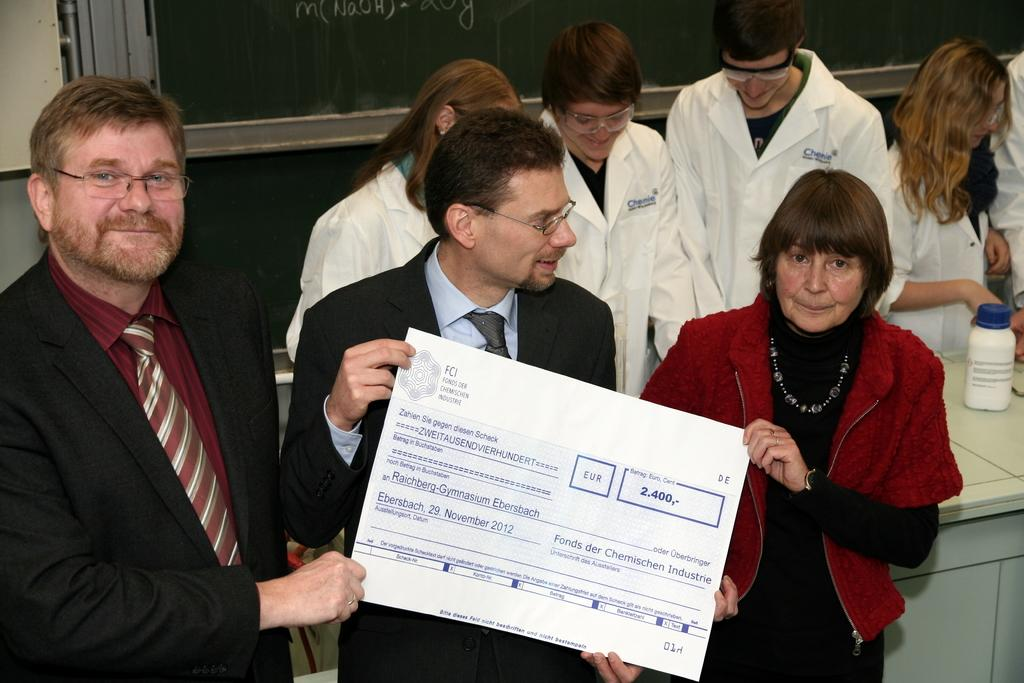How many people are holding a paper in the image? There are three people holding a paper in the image. Can you describe the people in the background of the image? There are other people in the background of the image. What can be seen in the background of the image besides people? There is a bottle and other objects visible in the background of the image. What type of fog can be seen in the image? There is no fog present in the image. Who is the creator of the objects in the image? The creator of the objects in the image is not mentioned or visible in the image. 